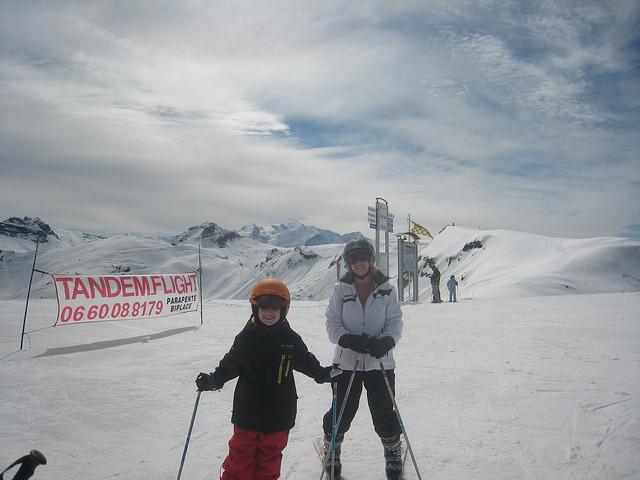What color is the goggles she is wearing?
Answer briefly. Black. Is this the same boy?
Answer briefly. No. What are the people doing?
Short answer required. Skiing. What phone number is shown?
Short answer required. 06 60 08 8179. What color is her jacket?
Answer briefly. White. How many people?
Keep it brief. 4. What country was this picture from?
Answer briefly. United states. What is hanging on the wire?
Be succinct. Sign. What color is the sign in the back?
Concise answer only. White. What is taller, the boy or the poles?
Short answer required. Boy. How many people are wearing their goggles?
Give a very brief answer. 2. 